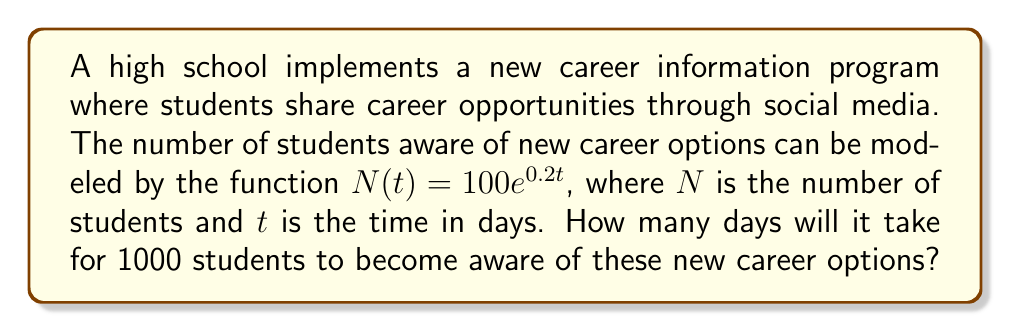Show me your answer to this math problem. To solve this problem, we need to use the exponential growth model given and solve for $t$ when $N(t) = 1000$.

1) We start with the equation:
   $N(t) = 100e^{0.2t}$

2) We want to find $t$ when $N(t) = 1000$, so we set up the equation:
   $1000 = 100e^{0.2t}$

3) Divide both sides by 100:
   $10 = e^{0.2t}$

4) Take the natural logarithm of both sides:
   $\ln(10) = \ln(e^{0.2t})$

5) Using the logarithm property $\ln(e^x) = x$:
   $\ln(10) = 0.2t$

6) Solve for $t$ by dividing both sides by 0.2:
   $t = \frac{\ln(10)}{0.2}$

7) Calculate the value:
   $t = \frac{\ln(10)}{0.2} \approx 11.51$ days

8) Since we're dealing with whole days, we round up to the next integer.

Therefore, it will take 12 days for 1000 students to become aware of the new career options.
Answer: 12 days 